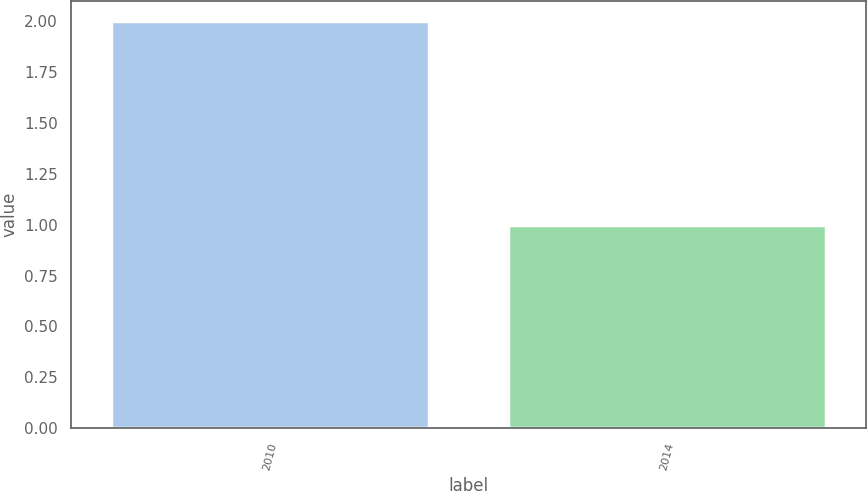<chart> <loc_0><loc_0><loc_500><loc_500><bar_chart><fcel>2010<fcel>2014<nl><fcel>2<fcel>1<nl></chart> 